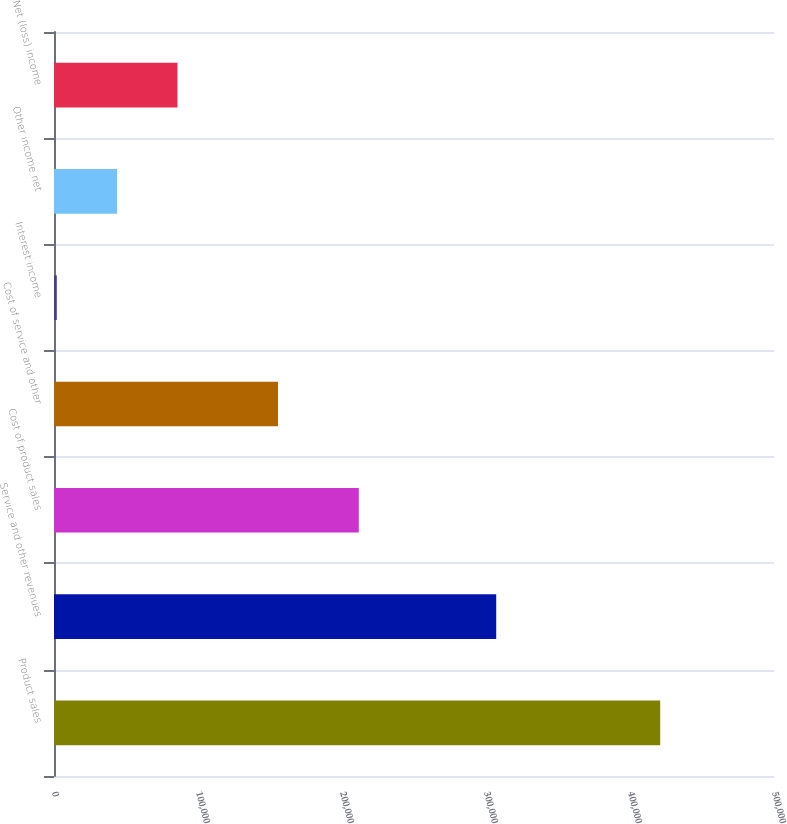<chart> <loc_0><loc_0><loc_500><loc_500><bar_chart><fcel>Product sales<fcel>Service and other revenues<fcel>Cost of product sales<fcel>Cost of service and other<fcel>Interest income<fcel>Other income net<fcel>Net (loss) income<nl><fcel>420960<fcel>307097<fcel>211665<fcel>155555<fcel>1950<fcel>43851<fcel>85752<nl></chart> 